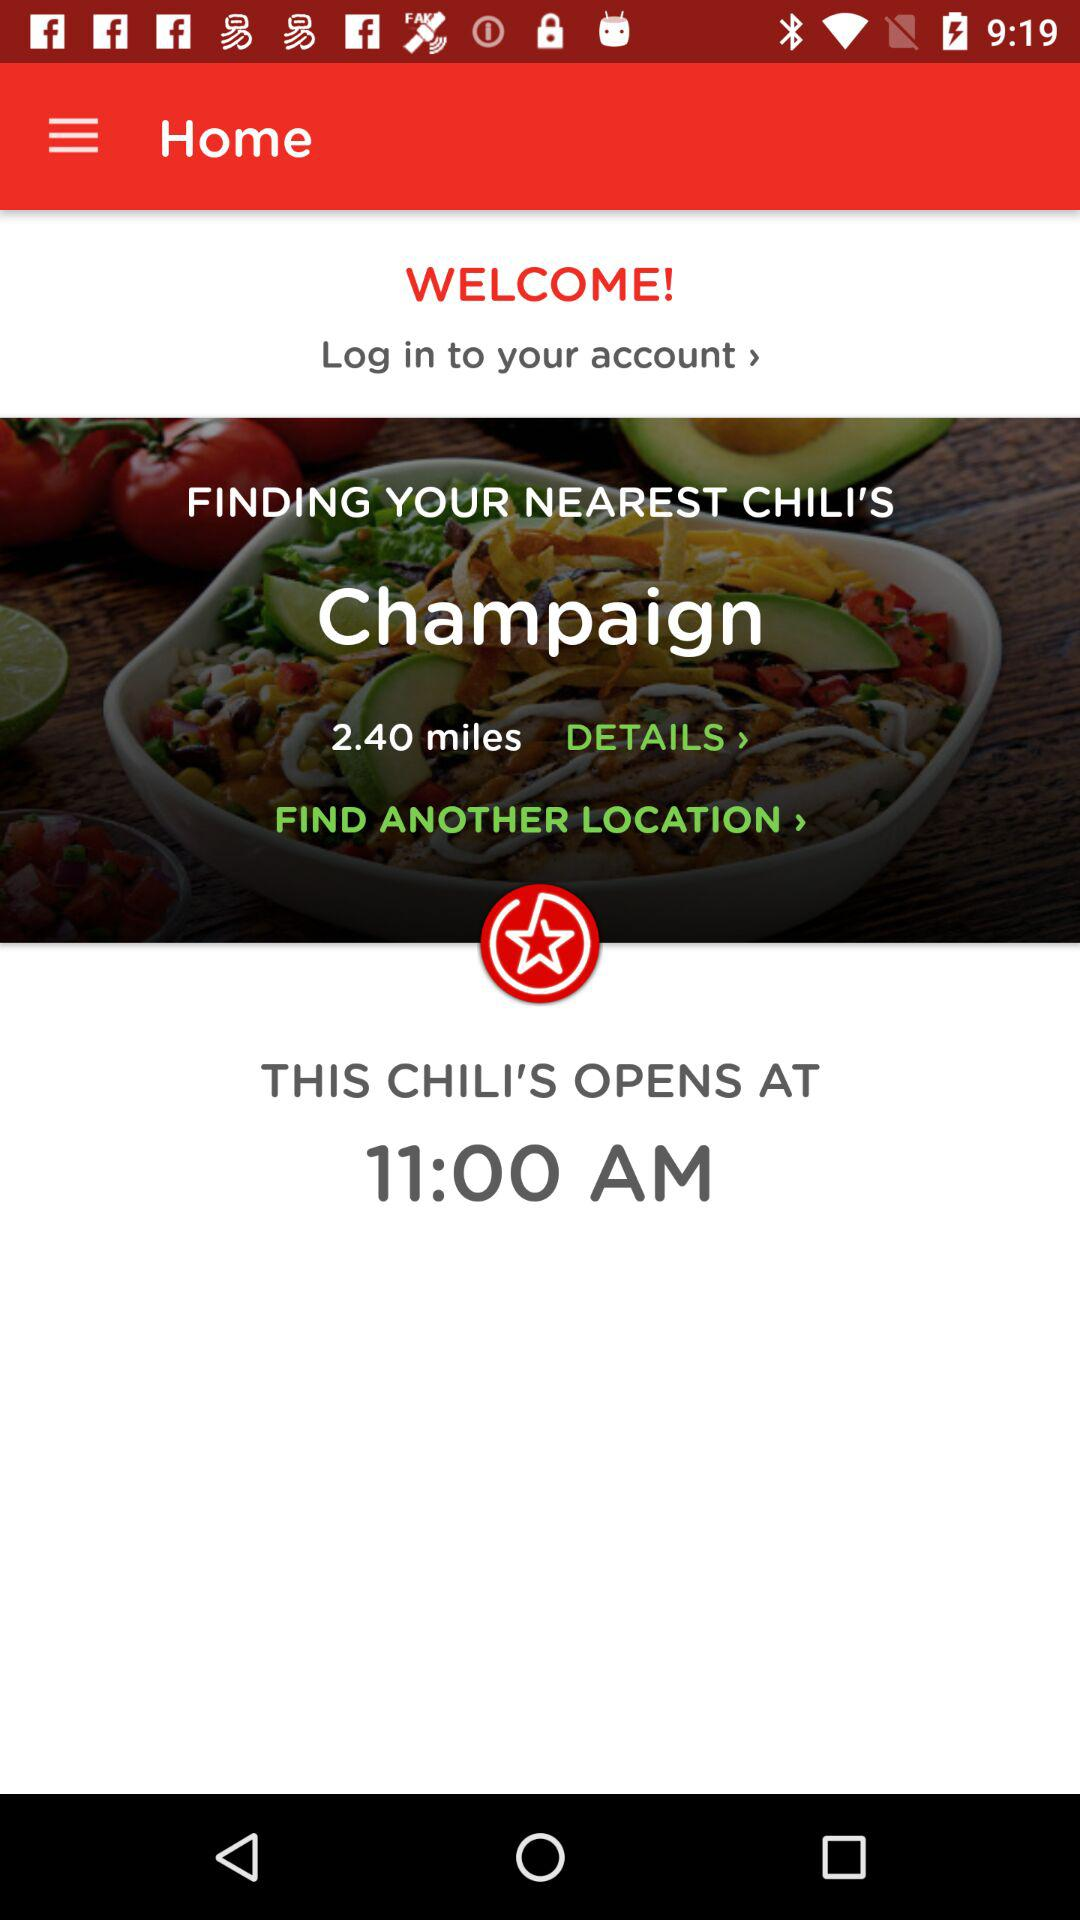At what time does the Chili's restaurant open? The Chili's restaurant opens at 11:00 AM. 